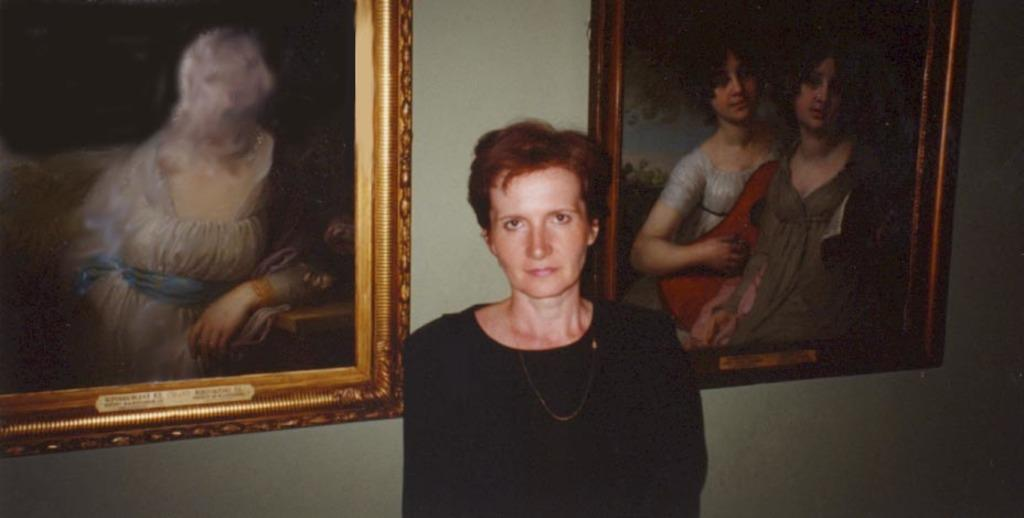What is the woman in the image wearing? The woman is wearing a black dress. How many photo frames are in the image? There are two photo frames in the image. Where are the photo frames located? The photo frames are attached to the wall. What might be contained within the photo frames? The photo frames may contain paintings. What type of riddle can be seen written on the wall in the image? There is no riddle visible in the image; it only features a woman, a black dress, and two photo frames. 